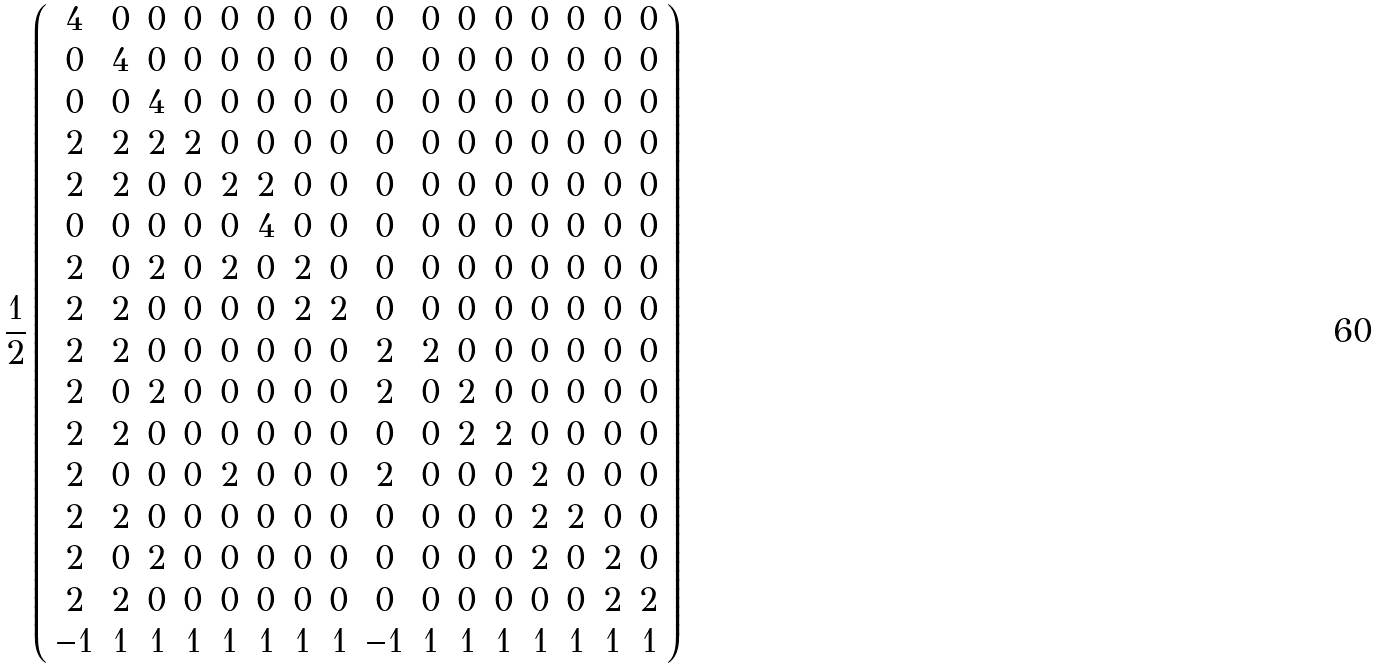Convert formula to latex. <formula><loc_0><loc_0><loc_500><loc_500>\frac { 1 } { 2 } \left ( \begin{array} { c c c c c c c c c c c c c c c c } 4 & 0 & 0 & 0 & 0 & 0 & 0 & 0 & 0 & 0 & 0 & 0 & 0 & 0 & 0 & 0 \\ 0 & 4 & 0 & 0 & 0 & 0 & 0 & 0 & 0 & 0 & 0 & 0 & 0 & 0 & 0 & 0 \\ 0 & 0 & 4 & 0 & 0 & 0 & 0 & 0 & 0 & 0 & 0 & 0 & 0 & 0 & 0 & 0 \\ 2 & 2 & 2 & 2 & 0 & 0 & 0 & 0 & 0 & 0 & 0 & 0 & 0 & 0 & 0 & 0 \\ 2 & 2 & 0 & 0 & 2 & 2 & 0 & 0 & 0 & 0 & 0 & 0 & 0 & 0 & 0 & 0 \\ 0 & 0 & 0 & 0 & 0 & 4 & 0 & 0 & 0 & 0 & 0 & 0 & 0 & 0 & 0 & 0 \\ 2 & 0 & 2 & 0 & 2 & 0 & 2 & 0 & 0 & 0 & 0 & 0 & 0 & 0 & 0 & 0 \\ 2 & 2 & 0 & 0 & 0 & 0 & 2 & 2 & 0 & 0 & 0 & 0 & 0 & 0 & 0 & 0 \\ 2 & 2 & 0 & 0 & 0 & 0 & 0 & 0 & 2 & 2 & 0 & 0 & 0 & 0 & 0 & 0 \\ 2 & 0 & 2 & 0 & 0 & 0 & 0 & 0 & 2 & 0 & 2 & 0 & 0 & 0 & 0 & 0 \\ 2 & 2 & 0 & 0 & 0 & 0 & 0 & 0 & 0 & 0 & 2 & 2 & 0 & 0 & 0 & 0 \\ 2 & 0 & 0 & 0 & 2 & 0 & 0 & 0 & 2 & 0 & 0 & 0 & 2 & 0 & 0 & 0 \\ 2 & 2 & 0 & 0 & 0 & 0 & 0 & 0 & 0 & 0 & 0 & 0 & 2 & 2 & 0 & 0 \\ 2 & 0 & 2 & 0 & 0 & 0 & 0 & 0 & 0 & 0 & 0 & 0 & 2 & 0 & 2 & 0 \\ 2 & 2 & 0 & 0 & 0 & 0 & 0 & 0 & 0 & 0 & 0 & 0 & 0 & 0 & 2 & 2 \\ - 1 & 1 & 1 & 1 & 1 & 1 & 1 & 1 & - 1 & 1 & 1 & 1 & 1 & 1 & 1 & 1 \end{array} \right )</formula> 